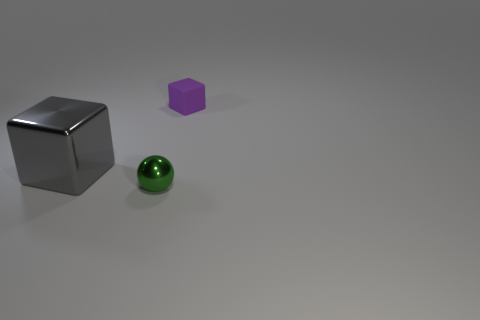Is there anything else that has the same size as the gray shiny block?
Make the answer very short. No. The metal block is what size?
Provide a succinct answer. Large. There is a object that is in front of the thing on the left side of the tiny green shiny thing; what is it made of?
Your answer should be very brief. Metal. Do the object that is right of the green metallic thing and the small green thing have the same size?
Your response must be concise. Yes. How many things are cubes that are in front of the small purple rubber thing or blocks that are behind the big thing?
Make the answer very short. 2. Is the large metal cube the same color as the matte object?
Keep it short and to the point. No. Are there fewer matte objects that are left of the large gray shiny thing than tiny shiny balls that are on the left side of the green shiny thing?
Provide a succinct answer. No. Does the big gray cube have the same material as the purple object?
Offer a very short reply. No. What size is the thing that is both behind the small metallic thing and on the right side of the big cube?
Give a very brief answer. Small. There is a rubber thing that is the same size as the green metal object; what shape is it?
Provide a succinct answer. Cube. 